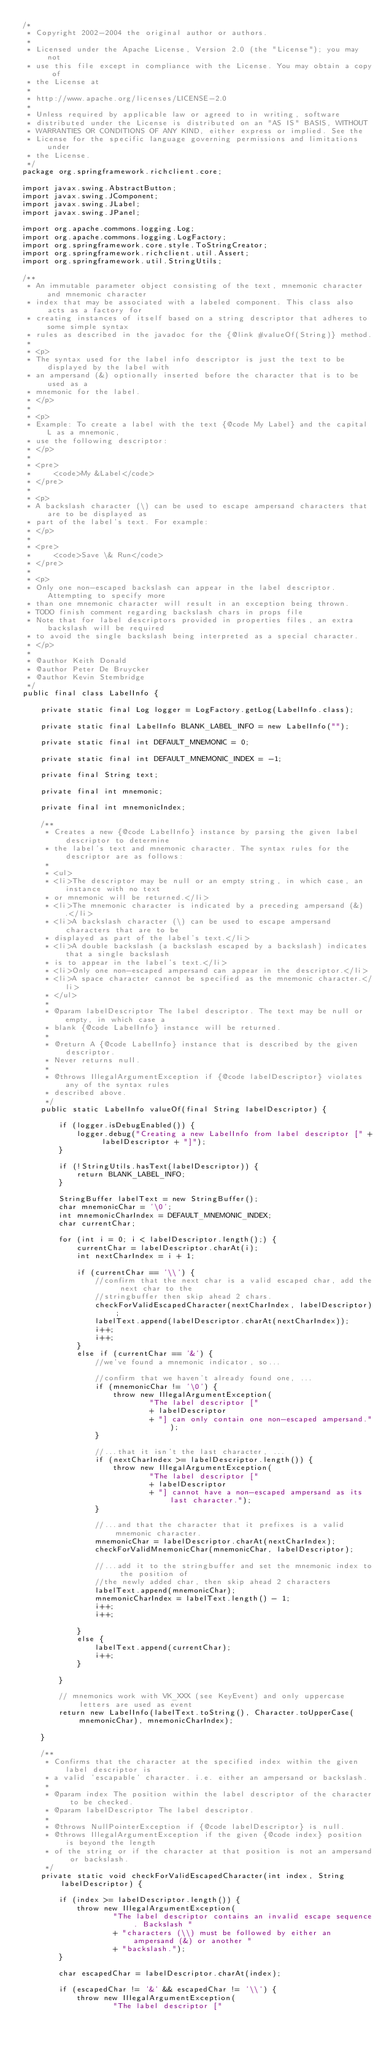Convert code to text. <code><loc_0><loc_0><loc_500><loc_500><_Java_>/*
 * Copyright 2002-2004 the original author or authors.
 *
 * Licensed under the Apache License, Version 2.0 (the "License"); you may not
 * use this file except in compliance with the License. You may obtain a copy of
 * the License at
 *
 * http://www.apache.org/licenses/LICENSE-2.0
 *
 * Unless required by applicable law or agreed to in writing, software
 * distributed under the License is distributed on an "AS IS" BASIS, WITHOUT
 * WARRANTIES OR CONDITIONS OF ANY KIND, either express or implied. See the
 * License for the specific language governing permissions and limitations under
 * the License.
 */
package org.springframework.richclient.core;

import javax.swing.AbstractButton;
import javax.swing.JComponent;
import javax.swing.JLabel;
import javax.swing.JPanel;

import org.apache.commons.logging.Log;
import org.apache.commons.logging.LogFactory;
import org.springframework.core.style.ToStringCreator;
import org.springframework.richclient.util.Assert;
import org.springframework.util.StringUtils;

/**
 * An immutable parameter object consisting of the text, mnemonic character and mnemonic character
 * index that may be associated with a labeled component. This class also acts as a factory for
 * creating instances of itself based on a string descriptor that adheres to some simple syntax
 * rules as described in the javadoc for the {@link #valueOf(String)} method.
 *
 * <p>
 * The syntax used for the label info descriptor is just the text to be displayed by the label with
 * an ampersand (&) optionally inserted before the character that is to be used as a
 * mnemonic for the label.
 * </p>
 *
 * <p>
 * Example: To create a label with the text {@code My Label} and the capital L as a mnemonic,
 * use the following descriptor:
 * </p>
 *
 * <pre>
 *     <code>My &Label</code>
 * </pre>
 *
 * <p>
 * A backslash character (\) can be used to escape ampersand characters that are to be displayed as
 * part of the label's text. For example:
 * </p>
 *
 * <pre>
 *     <code>Save \& Run</code>
 * </pre>
 *
 * <p>
 * Only one non-escaped backslash can appear in the label descriptor. Attempting to specify more
 * than one mnemonic character will result in an exception being thrown.
 * TODO finish comment regarding backslash chars in props file
 * Note that for label descriptors provided in properties files, an extra backslash will be required
 * to avoid the single backslash being interpreted as a special character.
 * </p>
 *
 * @author Keith Donald
 * @author Peter De Bruycker
 * @author Kevin Stembridge
 */
public final class LabelInfo {

    private static final Log logger = LogFactory.getLog(LabelInfo.class);

    private static final LabelInfo BLANK_LABEL_INFO = new LabelInfo("");

    private static final int DEFAULT_MNEMONIC = 0;

    private static final int DEFAULT_MNEMONIC_INDEX = -1;

    private final String text;

    private final int mnemonic;

    private final int mnemonicIndex;

    /**
     * Creates a new {@code LabelInfo} instance by parsing the given label descriptor to determine
     * the label's text and mnemonic character. The syntax rules for the descriptor are as follows:
     *
     * <ul>
     * <li>The descriptor may be null or an empty string, in which case, an instance with no text
     * or mnemonic will be returned.</li>
     * <li>The mnemonic character is indicated by a preceding ampersand (&).</li>
     * <li>A backslash character (\) can be used to escape ampersand characters that are to be
     * displayed as part of the label's text.</li>
     * <li>A double backslash (a backslash escaped by a backslash) indicates that a single backslash
     * is to appear in the label's text.</li>
     * <li>Only one non-escaped ampersand can appear in the descriptor.</li>
     * <li>A space character cannot be specified as the mnemonic character.</li>
     * </ul>
     *
     * @param labelDescriptor The label descriptor. The text may be null or empty, in which case a
     * blank {@code LabelInfo} instance will be returned.
     *
     * @return A {@code LabelInfo} instance that is described by the given descriptor.
     * Never returns null.
     *
     * @throws IllegalArgumentException if {@code labelDescriptor} violates any of the syntax rules
     * described above.
     */
    public static LabelInfo valueOf(final String labelDescriptor) {

        if (logger.isDebugEnabled()) {
            logger.debug("Creating a new LabelInfo from label descriptor [" + labelDescriptor + "]");
        }

        if (!StringUtils.hasText(labelDescriptor)) {
            return BLANK_LABEL_INFO;
        }

        StringBuffer labelText = new StringBuffer();
        char mnemonicChar = '\0';
        int mnemonicCharIndex = DEFAULT_MNEMONIC_INDEX;
        char currentChar;

        for (int i = 0; i < labelDescriptor.length();) {
            currentChar = labelDescriptor.charAt(i);
            int nextCharIndex = i + 1;

            if (currentChar == '\\') {
                //confirm that the next char is a valid escaped char, add the next char to the
                //stringbuffer then skip ahead 2 chars.
                checkForValidEscapedCharacter(nextCharIndex, labelDescriptor);
                labelText.append(labelDescriptor.charAt(nextCharIndex));
                i++;
                i++;
            }
            else if (currentChar == '&') {
                //we've found a mnemonic indicator, so...

                //confirm that we haven't already found one, ...
                if (mnemonicChar != '\0') {
                    throw new IllegalArgumentException(
                            "The label descriptor ["
                            + labelDescriptor
                            + "] can only contain one non-escaped ampersand.");
                }

                //...that it isn't the last character, ...
                if (nextCharIndex >= labelDescriptor.length()) {
                    throw new IllegalArgumentException(
                            "The label descriptor ["
                            + labelDescriptor
                            + "] cannot have a non-escaped ampersand as its last character.");
                }

                //...and that the character that it prefixes is a valid mnemonic character.
                mnemonicChar = labelDescriptor.charAt(nextCharIndex);
                checkForValidMnemonicChar(mnemonicChar, labelDescriptor);

                //...add it to the stringbuffer and set the mnemonic index to the position of
                //the newly added char, then skip ahead 2 characters
                labelText.append(mnemonicChar);
                mnemonicCharIndex = labelText.length() - 1;
                i++;
                i++;

            }
            else {
                labelText.append(currentChar);
                i++;
            }

        }

        // mnemonics work with VK_XXX (see KeyEvent) and only uppercase letters are used as event
        return new LabelInfo(labelText.toString(), Character.toUpperCase(mnemonicChar), mnemonicCharIndex);

    }

    /**
     * Confirms that the character at the specified index within the given label descriptor is
     * a valid 'escapable' character. i.e. either an ampersand or backslash.
     *
     * @param index The position within the label descriptor of the character to be checked.
     * @param labelDescriptor The label descriptor.
     *
     * @throws NullPointerException if {@code labelDescriptor} is null.
     * @throws IllegalArgumentException if the given {@code index} position is beyond the length
     * of the string or if the character at that position is not an ampersand or backslash.
     */
    private static void checkForValidEscapedCharacter(int index, String labelDescriptor) {

        if (index >= labelDescriptor.length()) {
            throw new IllegalArgumentException(
                    "The label descriptor contains an invalid escape sequence. Backslash "
                    + "characters (\\) must be followed by either an ampersand (&) or another "
                    + "backslash.");
        }

        char escapedChar = labelDescriptor.charAt(index);

        if (escapedChar != '&' && escapedChar != '\\') {
            throw new IllegalArgumentException(
                    "The label descriptor ["</code> 